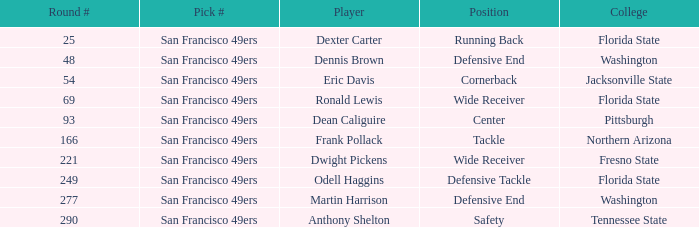What is the College with a Player that is dean caliguire? Pittsburgh. 